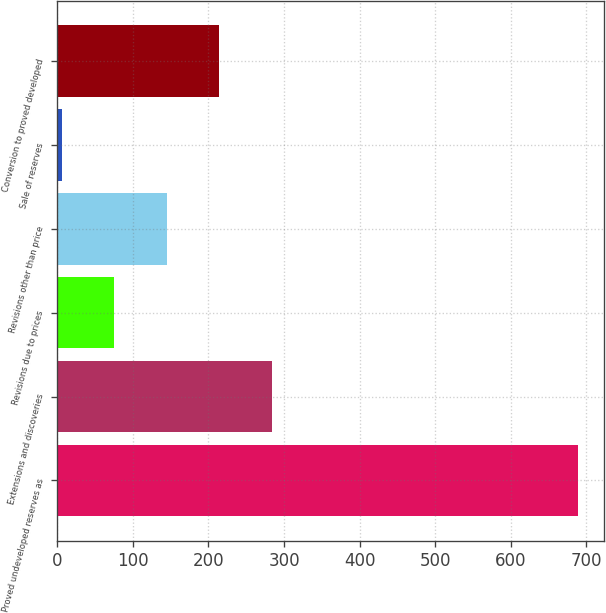<chart> <loc_0><loc_0><loc_500><loc_500><bar_chart><fcel>Proved undeveloped reserves as<fcel>Extensions and discoveries<fcel>Revisions due to prices<fcel>Revisions other than price<fcel>Sale of reserves<fcel>Conversion to proved developed<nl><fcel>689<fcel>284<fcel>75.5<fcel>145<fcel>6<fcel>214.5<nl></chart> 